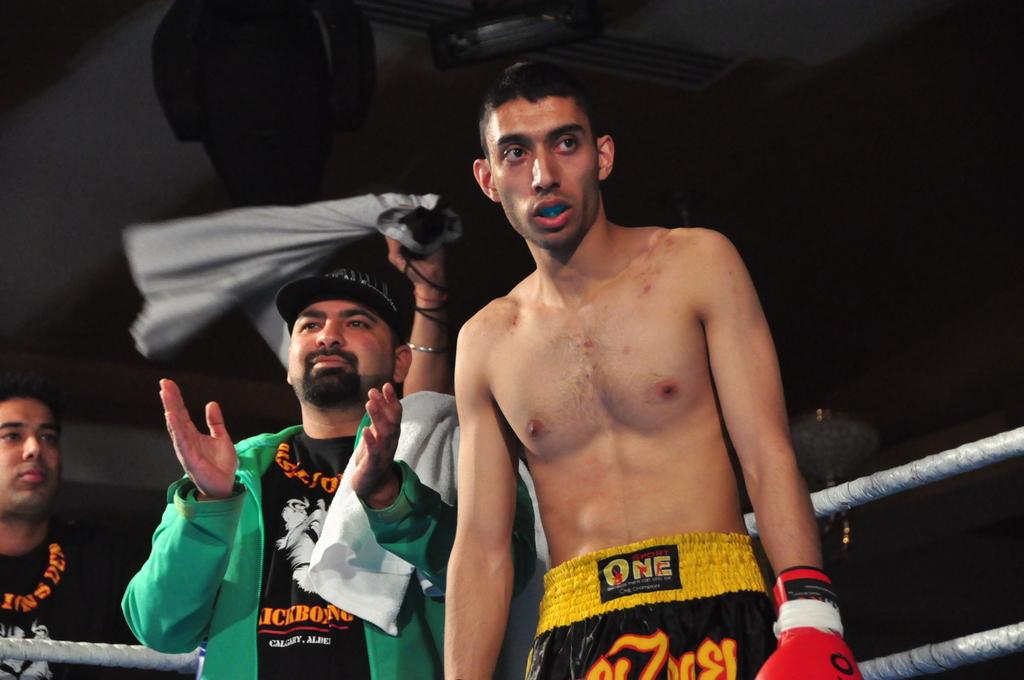<image>
Provide a brief description of the given image. a man that is wearing shorts that say one on it 